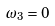Convert formula to latex. <formula><loc_0><loc_0><loc_500><loc_500>\omega _ { 3 } = 0</formula> 